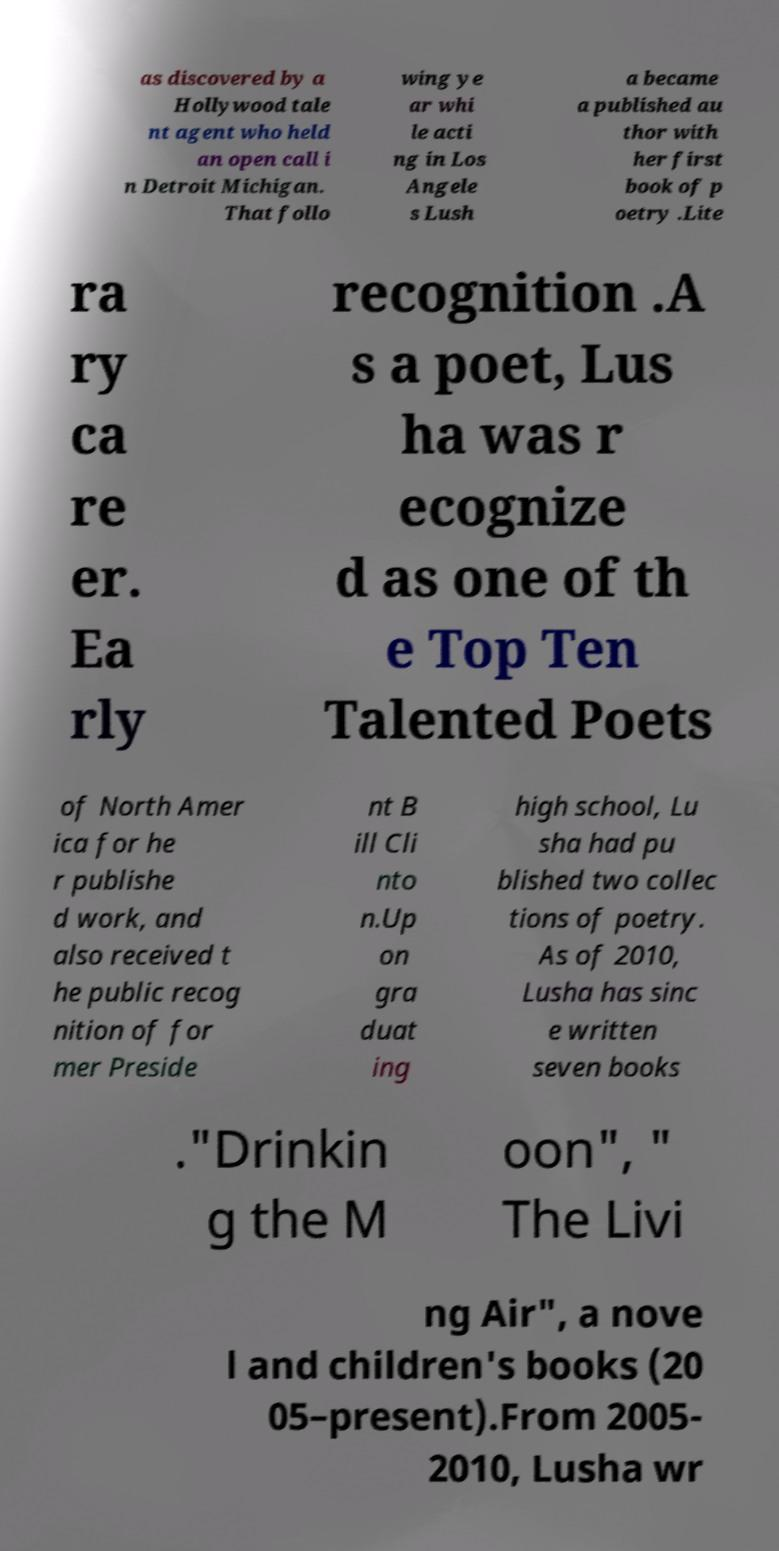There's text embedded in this image that I need extracted. Can you transcribe it verbatim? as discovered by a Hollywood tale nt agent who held an open call i n Detroit Michigan. That follo wing ye ar whi le acti ng in Los Angele s Lush a became a published au thor with her first book of p oetry .Lite ra ry ca re er. Ea rly recognition .A s a poet, Lus ha was r ecognize d as one of th e Top Ten Talented Poets of North Amer ica for he r publishe d work, and also received t he public recog nition of for mer Preside nt B ill Cli nto n.Up on gra duat ing high school, Lu sha had pu blished two collec tions of poetry. As of 2010, Lusha has sinc e written seven books ."Drinkin g the M oon", " The Livi ng Air", a nove l and children's books (20 05–present).From 2005- 2010, Lusha wr 